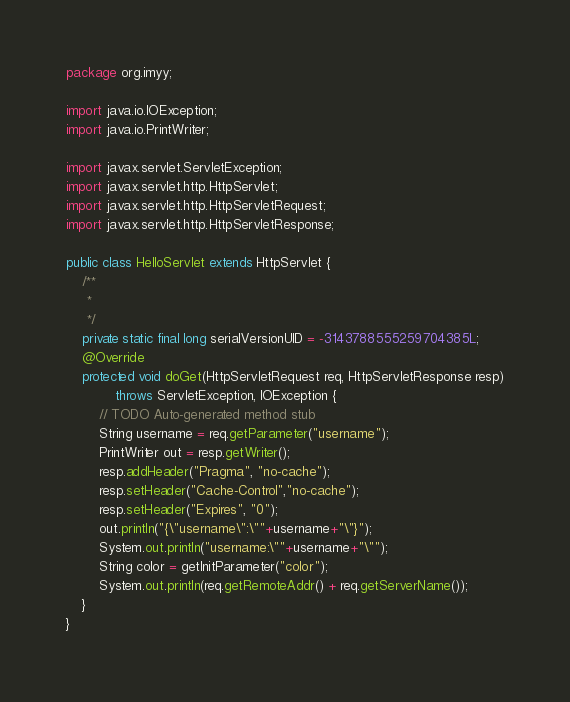<code> <loc_0><loc_0><loc_500><loc_500><_Java_>package org.imyy;

import java.io.IOException;
import java.io.PrintWriter;

import javax.servlet.ServletException;
import javax.servlet.http.HttpServlet;
import javax.servlet.http.HttpServletRequest;
import javax.servlet.http.HttpServletResponse;

public class HelloServlet extends HttpServlet {
	/**
	 * 
	 */
	private static final long serialVersionUID = -3143788555259704385L;
	@Override
	protected void doGet(HttpServletRequest req, HttpServletResponse resp)
			throws ServletException, IOException {
		// TODO Auto-generated method stub
		String username = req.getParameter("username");
		PrintWriter out = resp.getWriter();
		resp.addHeader("Pragma", "no-cache");
		resp.setHeader("Cache-Control","no-cache");
		resp.setHeader("Expires", "0");
		out.println("{\"username\":\""+username+"\"}");
		System.out.println("username:\""+username+"\"");
		String color = getInitParameter("color");
		System.out.println(req.getRemoteAddr() + req.getServerName());
	}
}
</code> 